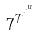<formula> <loc_0><loc_0><loc_500><loc_500>7 ^ { 7 ^ { \cdot ^ { \cdot ^ { \cdot ^ { u } } } } }</formula> 